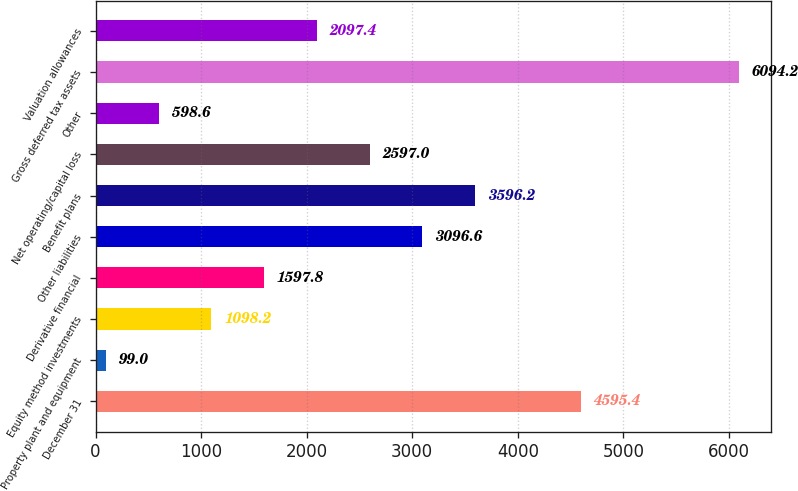Convert chart. <chart><loc_0><loc_0><loc_500><loc_500><bar_chart><fcel>December 31<fcel>Property plant and equipment<fcel>Equity method investments<fcel>Derivative financial<fcel>Other liabilities<fcel>Benefit plans<fcel>Net operating/capital loss<fcel>Other<fcel>Gross deferred tax assets<fcel>Valuation allowances<nl><fcel>4595.4<fcel>99<fcel>1098.2<fcel>1597.8<fcel>3096.6<fcel>3596.2<fcel>2597<fcel>598.6<fcel>6094.2<fcel>2097.4<nl></chart> 